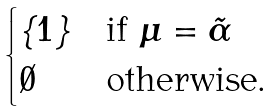Convert formula to latex. <formula><loc_0><loc_0><loc_500><loc_500>\begin{cases} \{ 1 \} & \text {if $\mu=\tilde{\alpha}$} \\ \emptyset & \text {otherwise.} \end{cases}</formula> 